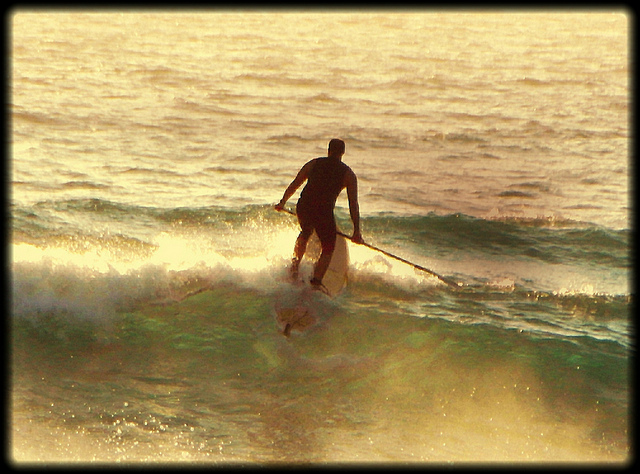What does the man use to help him catch the wave? The man uses a long paddle to help him catch and ride the wave. He uses the paddle not only for propulsion and steering but also to maintain his balance on the paddleboard. 